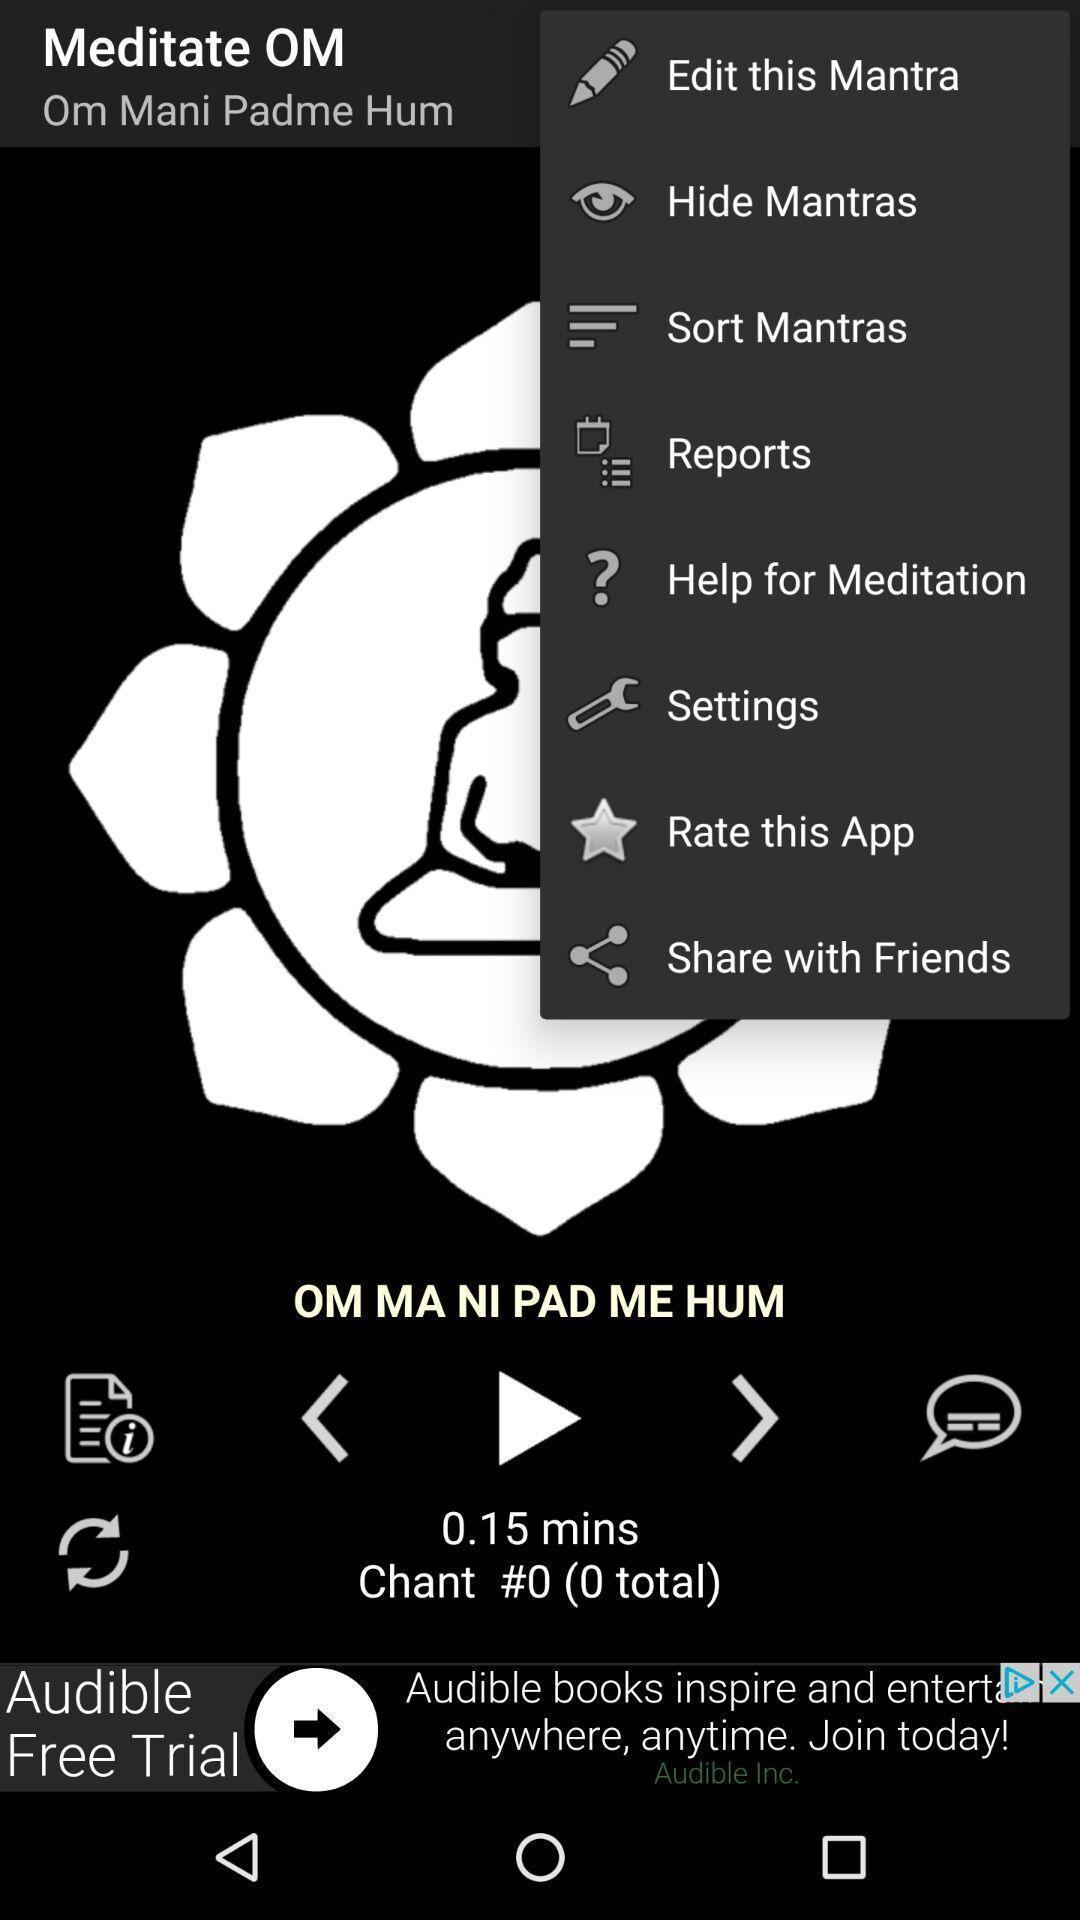Describe the content in this image. Screen shows multiple options in a music application. 